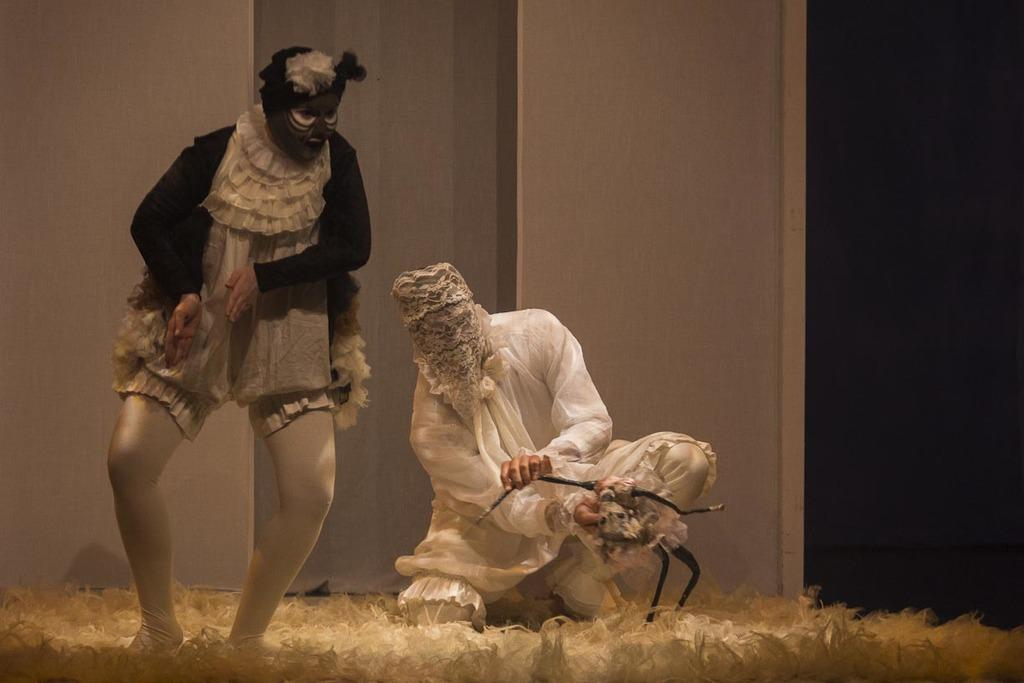How many people are in the image? There are two people in the image. What are the people wearing on their faces? The people are wearing masks. What can be seen in the background of the image? There is a wall in the background of the image. What color is the surface at the bottom of the image? The surface at the bottom of the image is white. Is there a boat visible in the image? No, there is no boat present in the image. What type of event is taking place in the image? There is no specific event taking place in the image; it simply shows two people wearing masks. 